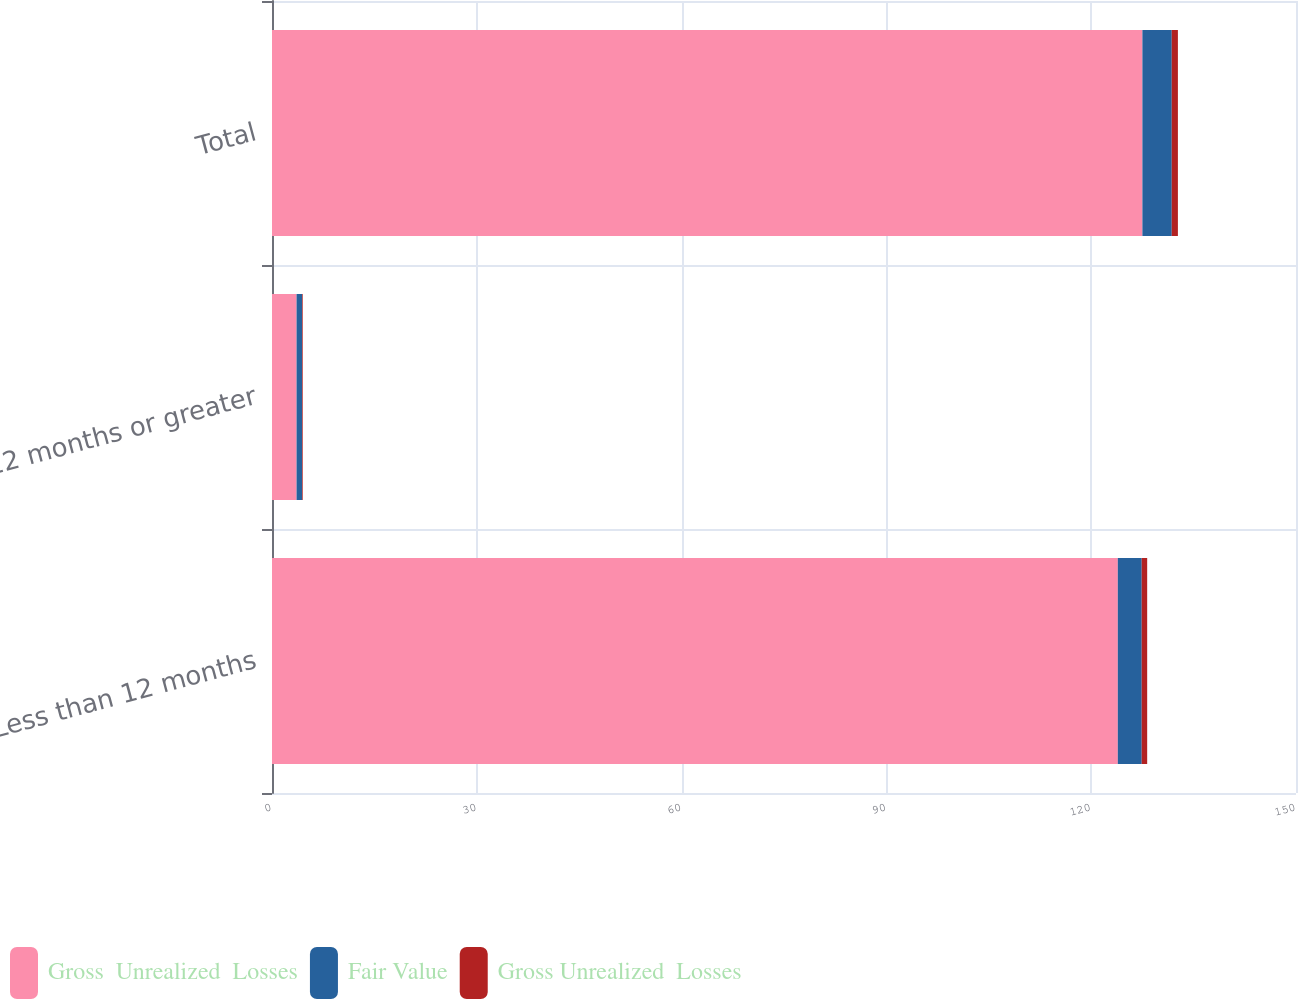<chart> <loc_0><loc_0><loc_500><loc_500><stacked_bar_chart><ecel><fcel>Less than 12 months<fcel>12 months or greater<fcel>Total<nl><fcel>Gross  Unrealized  Losses<fcel>123.9<fcel>3.6<fcel>127.5<nl><fcel>Fair Value<fcel>3.5<fcel>0.8<fcel>4.3<nl><fcel>Gross Unrealized  Losses<fcel>0.8<fcel>0.1<fcel>0.9<nl></chart> 